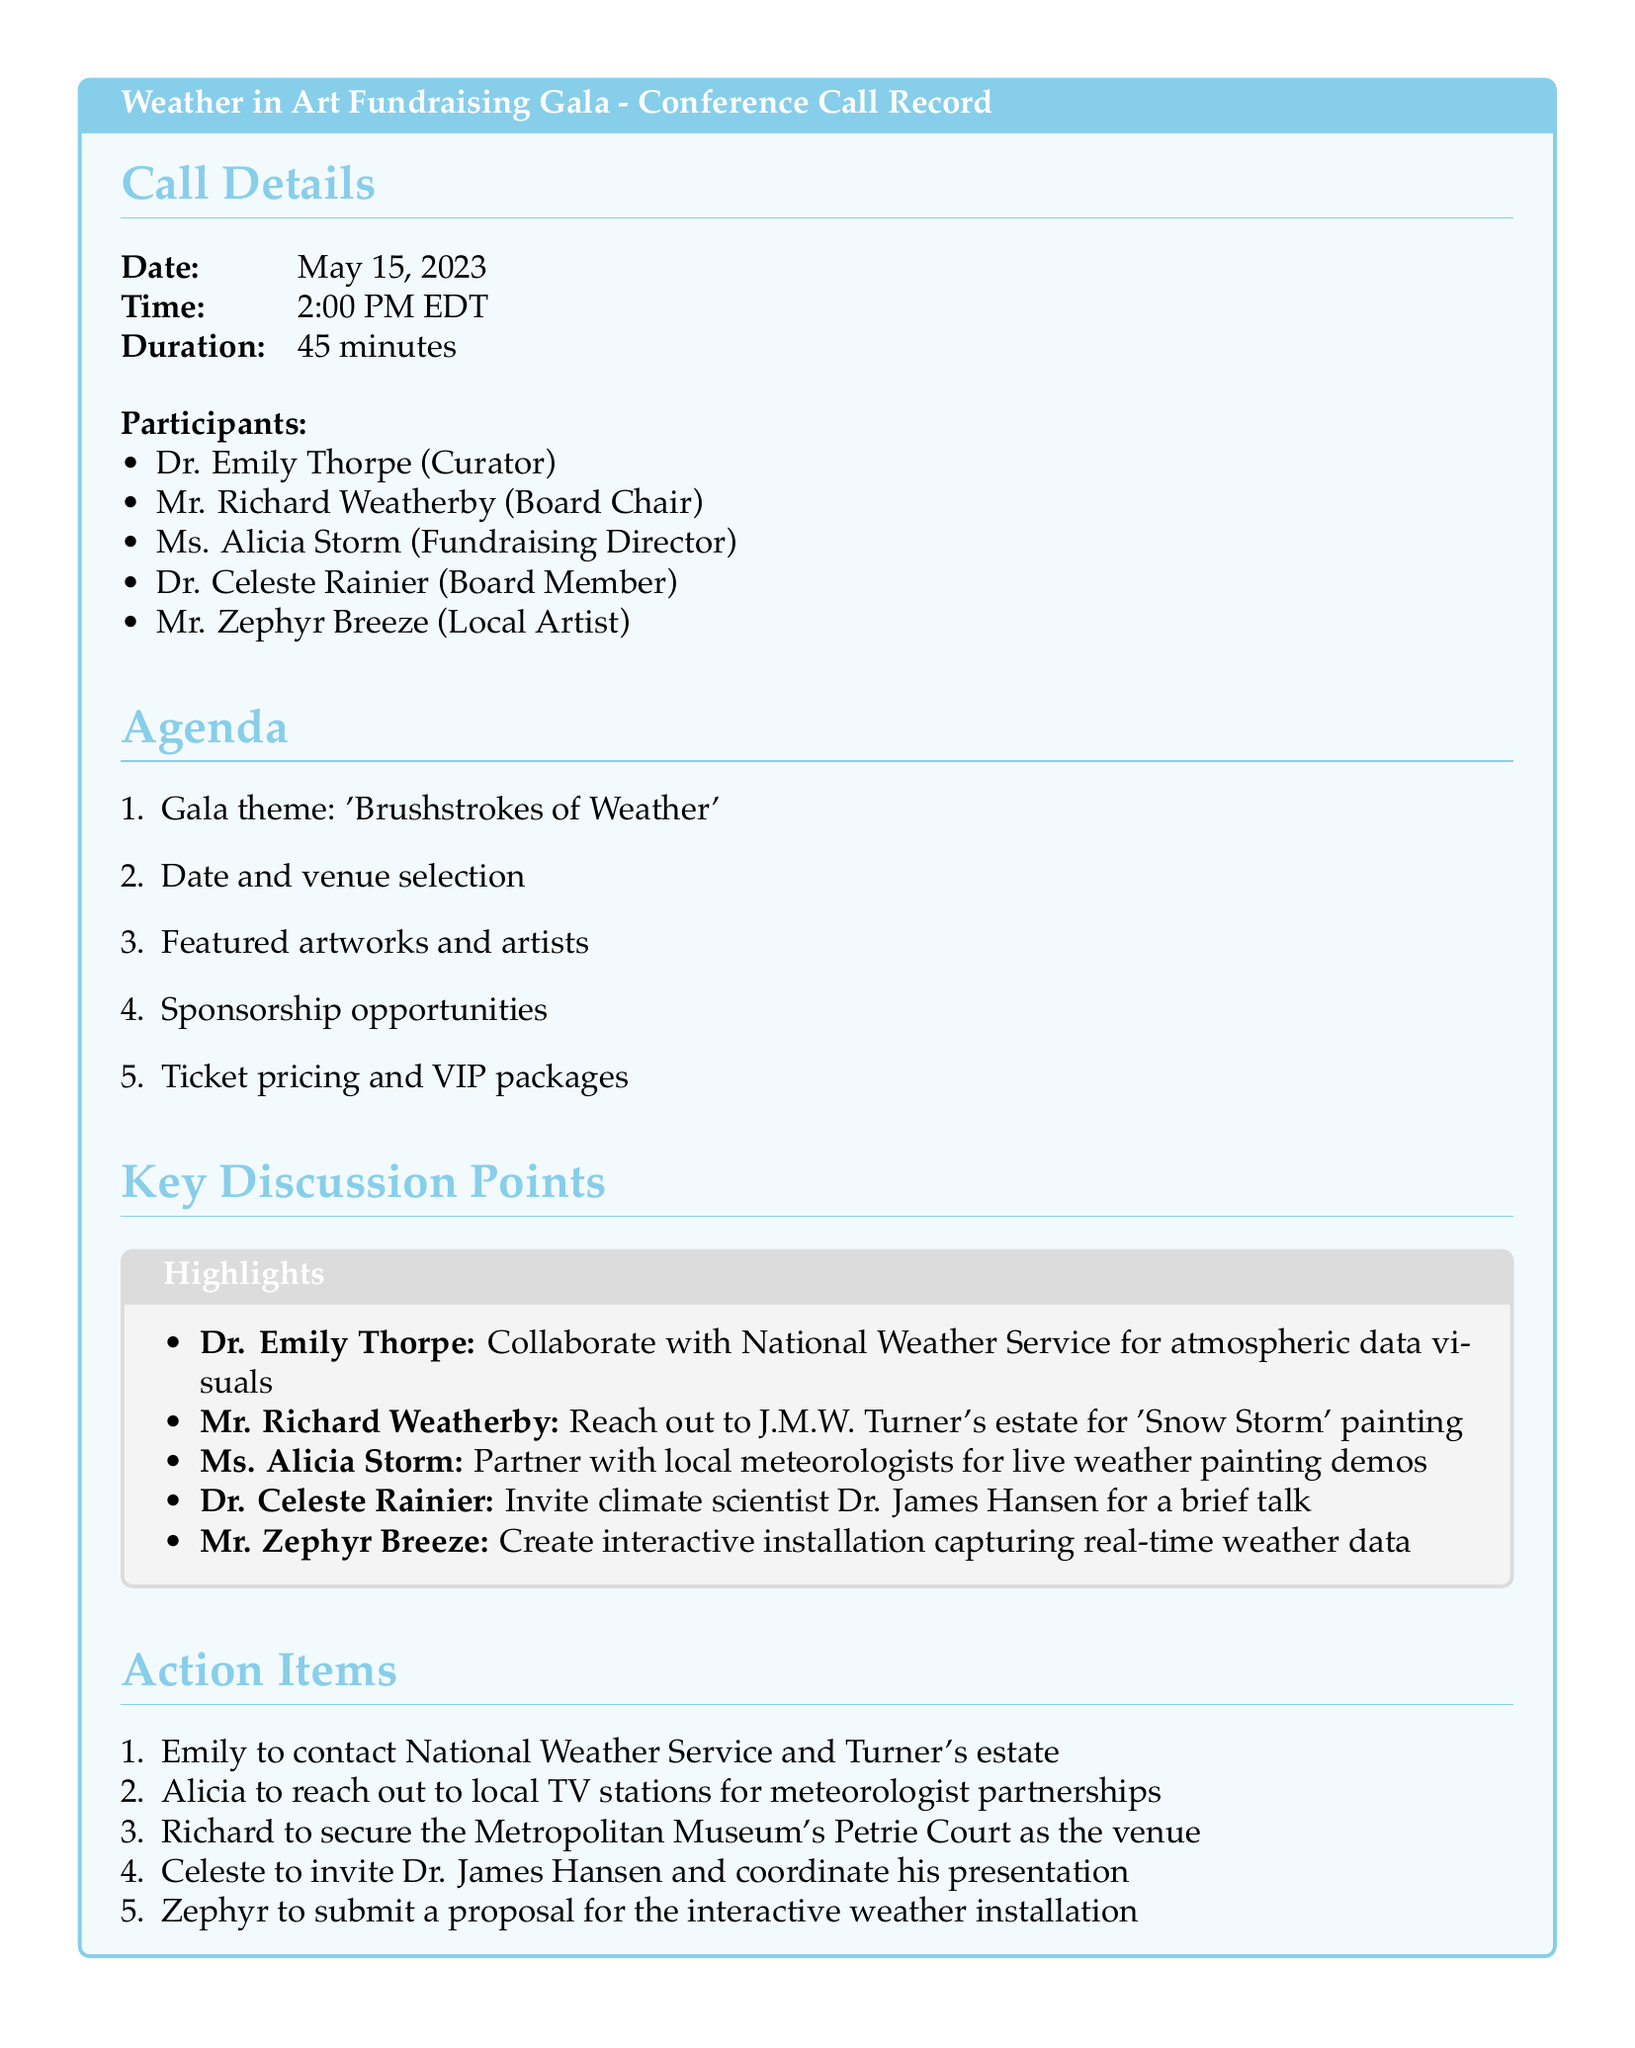What is the date of the conference call? The date is specified in the call details section of the document.
Answer: May 15, 2023 Who is the Fundraising Director? The document lists the participants and their roles, identifying Ms. Alicia Storm as the Fundraising Director.
Answer: Ms. Alicia Storm What is the theme of the gala? The theme is outlined in the agenda section of the document.
Answer: Brushstrokes of Weather Which board member is responsible for inviting Dr. James Hansen? The action items assign this responsibility to Dr. Celeste Rainier.
Answer: Dr. Celeste Rainier How long did the conference call last? The duration of the call is mentioned in the call details.
Answer: 45 minutes What will be created by Mr. Zephyr Breeze? The document specifies that he will create an interactive installation.
Answer: Interactive installation What venue is Richard supposed to secure? The document lists Richard's responsibility regarding the venue selection.
Answer: Metropolitan Museum's Petrie Court What is one proposed partnership for the gala? The key discussion points mention several partnerships, including collaboration with local meteorologists.
Answer: Local meteorologists Who suggested collaborating with the National Weather Service? The document attributes this suggestion to Dr. Emily Thorpe.
Answer: Dr. Emily Thorpe 